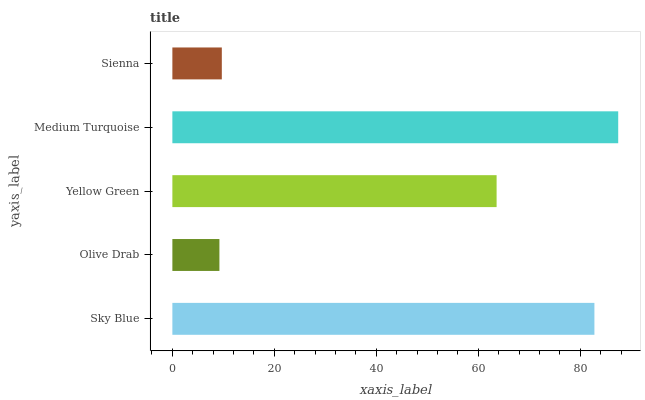Is Olive Drab the minimum?
Answer yes or no. Yes. Is Medium Turquoise the maximum?
Answer yes or no. Yes. Is Yellow Green the minimum?
Answer yes or no. No. Is Yellow Green the maximum?
Answer yes or no. No. Is Yellow Green greater than Olive Drab?
Answer yes or no. Yes. Is Olive Drab less than Yellow Green?
Answer yes or no. Yes. Is Olive Drab greater than Yellow Green?
Answer yes or no. No. Is Yellow Green less than Olive Drab?
Answer yes or no. No. Is Yellow Green the high median?
Answer yes or no. Yes. Is Yellow Green the low median?
Answer yes or no. Yes. Is Olive Drab the high median?
Answer yes or no. No. Is Sienna the low median?
Answer yes or no. No. 